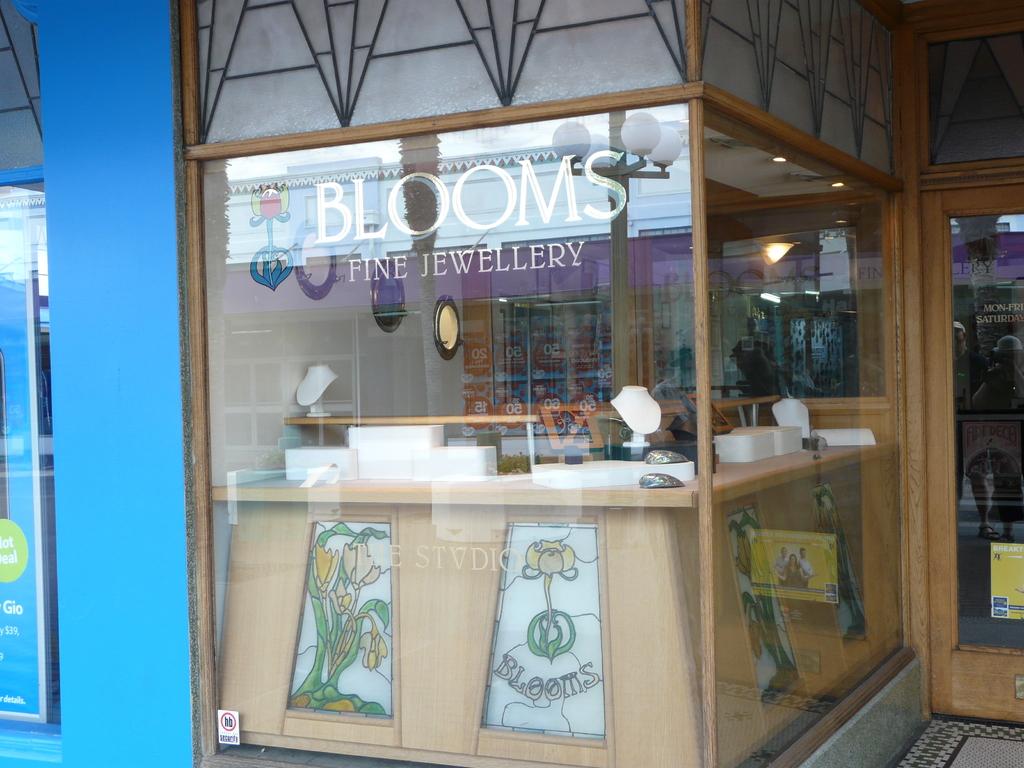What type of store is this?
Provide a succinct answer. Jewellery. 